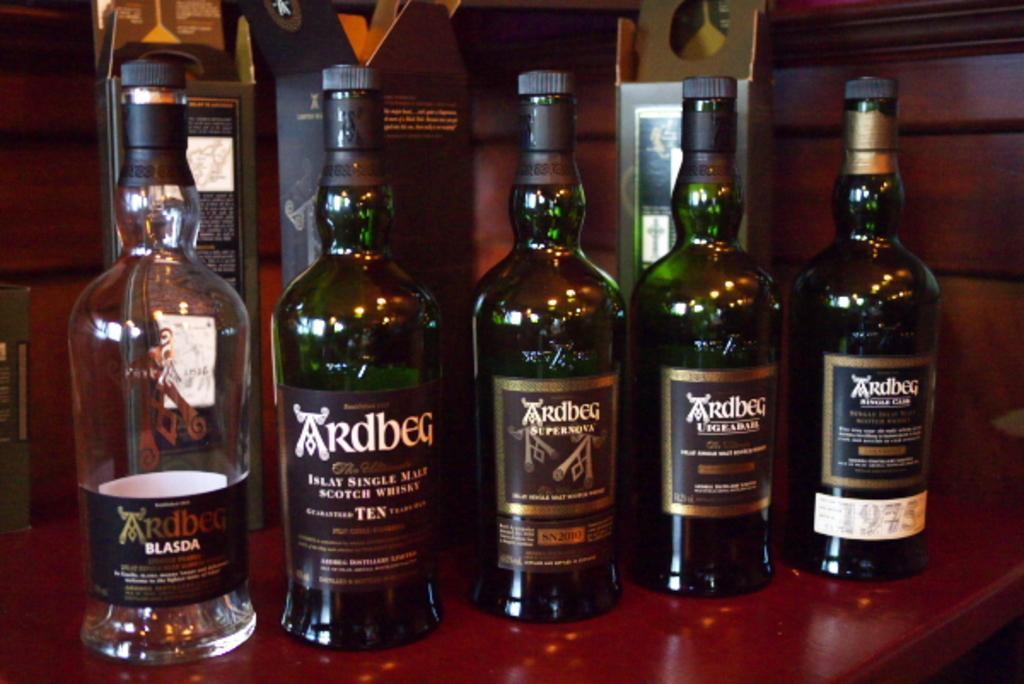Please provide a concise description of this image. In this image I can see if few glass bottles and few glass bottle covers. 